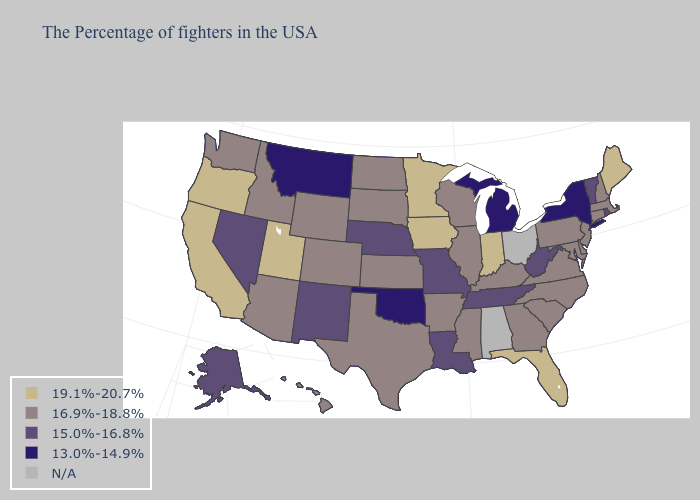Name the states that have a value in the range N/A?
Keep it brief. Ohio, Alabama. Among the states that border Missouri , which have the highest value?
Be succinct. Iowa. Name the states that have a value in the range 16.9%-18.8%?
Answer briefly. Massachusetts, New Hampshire, Connecticut, New Jersey, Delaware, Maryland, Pennsylvania, Virginia, North Carolina, South Carolina, Georgia, Kentucky, Wisconsin, Illinois, Mississippi, Arkansas, Kansas, Texas, South Dakota, North Dakota, Wyoming, Colorado, Arizona, Idaho, Washington, Hawaii. Which states have the lowest value in the USA?
Write a very short answer. New York, Michigan, Oklahoma, Montana. Which states have the lowest value in the USA?
Concise answer only. New York, Michigan, Oklahoma, Montana. What is the lowest value in the USA?
Give a very brief answer. 13.0%-14.9%. Name the states that have a value in the range N/A?
Quick response, please. Ohio, Alabama. Name the states that have a value in the range N/A?
Answer briefly. Ohio, Alabama. Name the states that have a value in the range 16.9%-18.8%?
Give a very brief answer. Massachusetts, New Hampshire, Connecticut, New Jersey, Delaware, Maryland, Pennsylvania, Virginia, North Carolina, South Carolina, Georgia, Kentucky, Wisconsin, Illinois, Mississippi, Arkansas, Kansas, Texas, South Dakota, North Dakota, Wyoming, Colorado, Arizona, Idaho, Washington, Hawaii. How many symbols are there in the legend?
Write a very short answer. 5. Which states have the lowest value in the USA?
Answer briefly. New York, Michigan, Oklahoma, Montana. Name the states that have a value in the range 13.0%-14.9%?
Short answer required. New York, Michigan, Oklahoma, Montana. Does West Virginia have the lowest value in the USA?
Be succinct. No. 